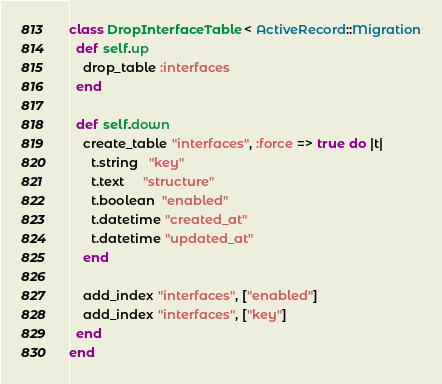<code> <loc_0><loc_0><loc_500><loc_500><_Ruby_>class DropInterfaceTable < ActiveRecord::Migration
  def self.up
    drop_table :interfaces
  end

  def self.down
    create_table "interfaces", :force => true do |t|
      t.string   "key"
      t.text     "structure"
      t.boolean  "enabled"
      t.datetime "created_at"
      t.datetime "updated_at"
    end

    add_index "interfaces", ["enabled"]
    add_index "interfaces", ["key"]
  end
end
</code> 